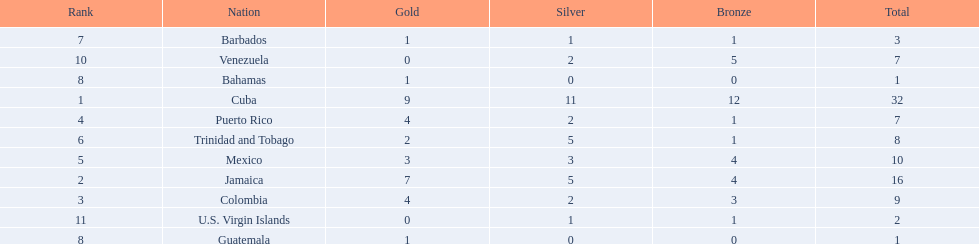Which teams have at exactly 4 gold medals? Colombia, Puerto Rico. Of those teams which has exactly 1 bronze medal? Puerto Rico. 